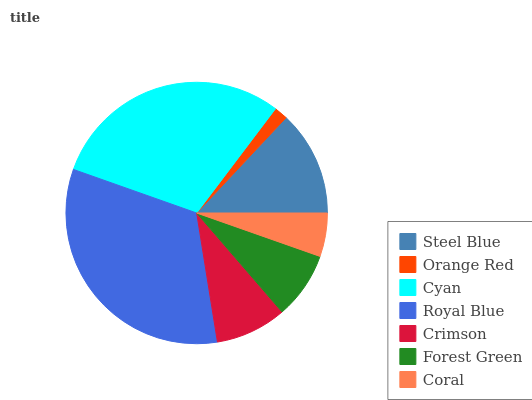Is Orange Red the minimum?
Answer yes or no. Yes. Is Royal Blue the maximum?
Answer yes or no. Yes. Is Cyan the minimum?
Answer yes or no. No. Is Cyan the maximum?
Answer yes or no. No. Is Cyan greater than Orange Red?
Answer yes or no. Yes. Is Orange Red less than Cyan?
Answer yes or no. Yes. Is Orange Red greater than Cyan?
Answer yes or no. No. Is Cyan less than Orange Red?
Answer yes or no. No. Is Crimson the high median?
Answer yes or no. Yes. Is Crimson the low median?
Answer yes or no. Yes. Is Forest Green the high median?
Answer yes or no. No. Is Royal Blue the low median?
Answer yes or no. No. 